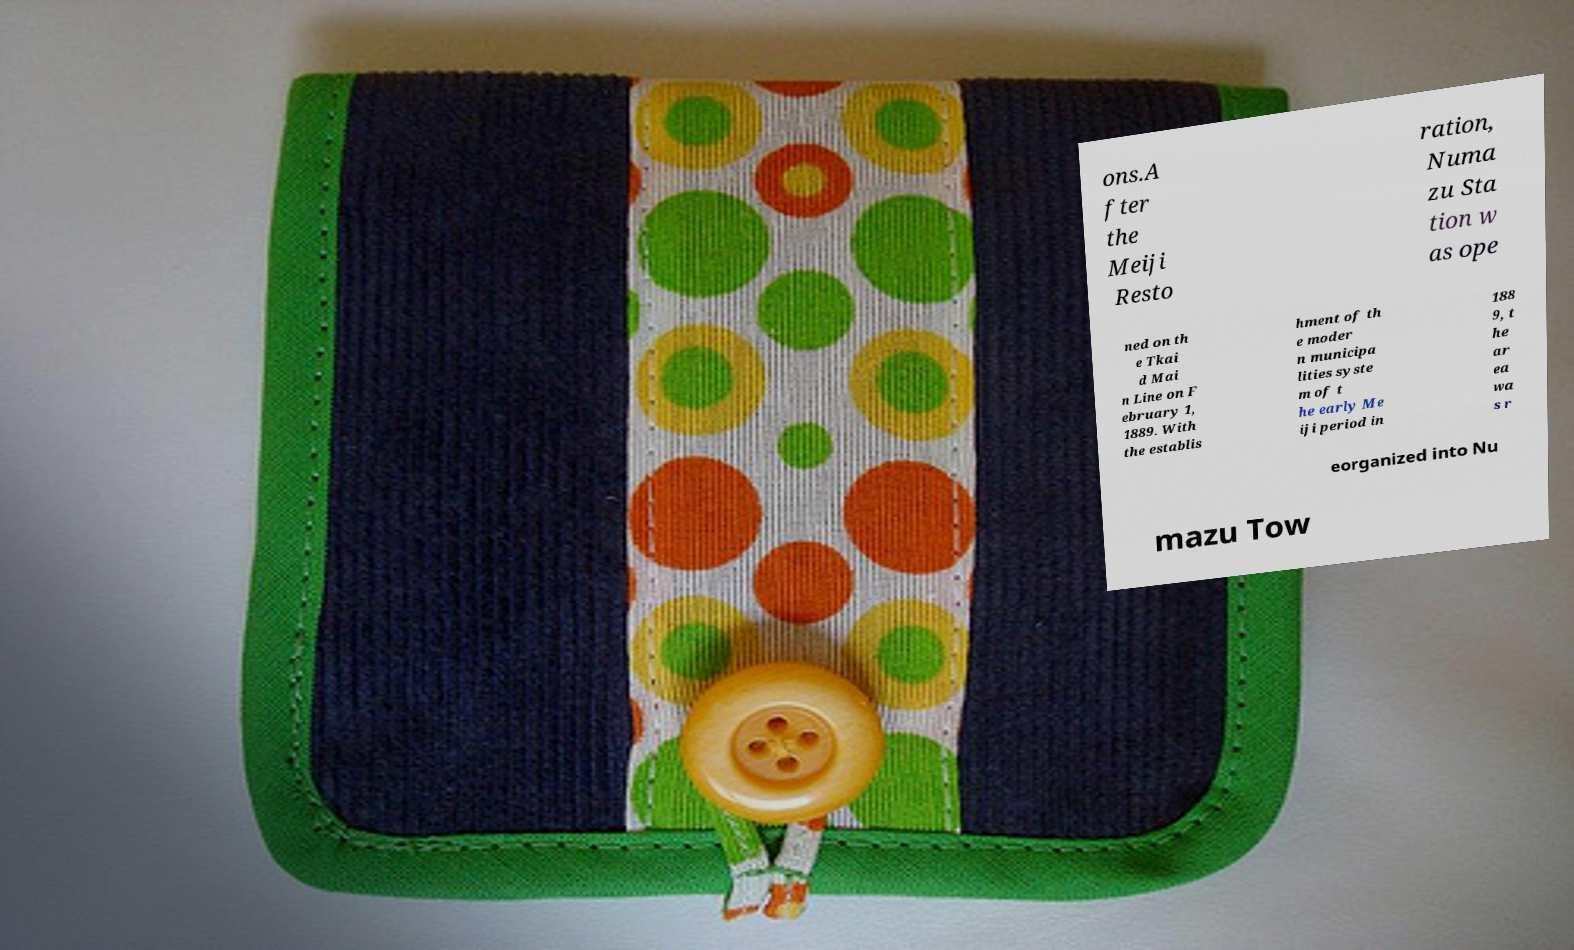Could you extract and type out the text from this image? ons.A fter the Meiji Resto ration, Numa zu Sta tion w as ope ned on th e Tkai d Mai n Line on F ebruary 1, 1889. With the establis hment of th e moder n municipa lities syste m of t he early Me iji period in 188 9, t he ar ea wa s r eorganized into Nu mazu Tow 